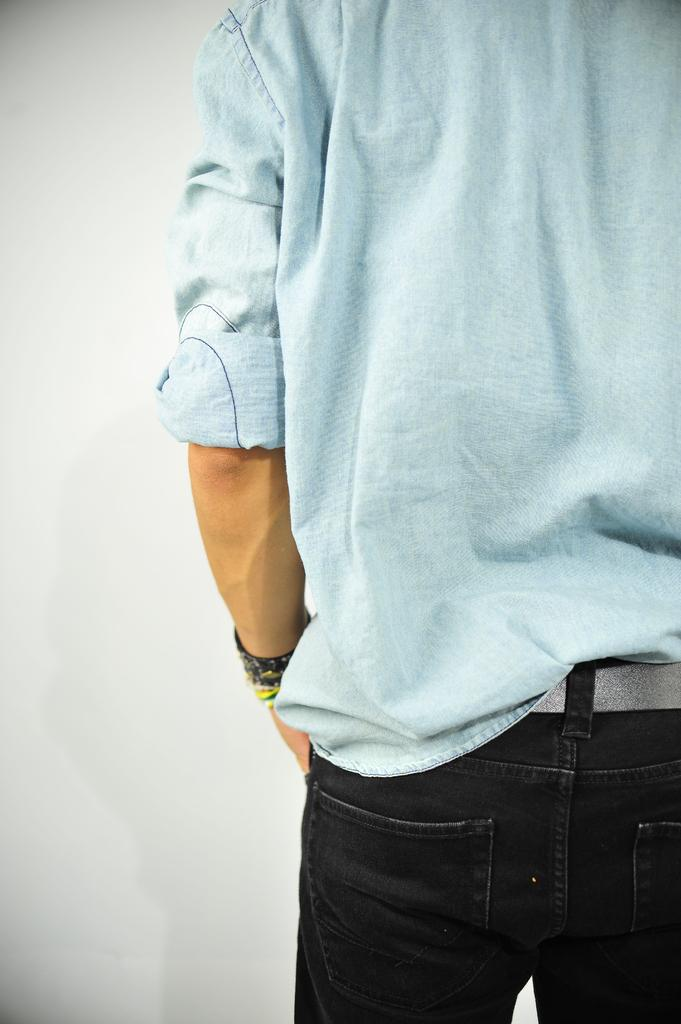What is the main subject of the image? There is a person in the image. Can you describe the person's position in the image? The person is standing in front. What color is the person's shirt? The person is wearing a blue shirt. What color are the person's jeans? The person is wearing black jeans. What color is the background of the image? The background of the image is white. Can you see the person's grandmother in the image? There is no mention of a grandmother in the image, so it cannot be determined if she is present. 